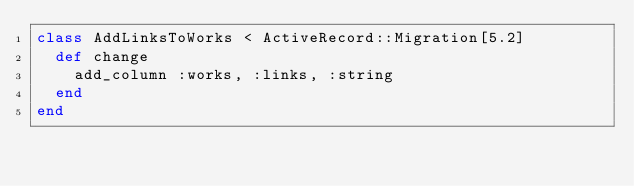Convert code to text. <code><loc_0><loc_0><loc_500><loc_500><_Ruby_>class AddLinksToWorks < ActiveRecord::Migration[5.2]
  def change
    add_column :works, :links, :string
  end
end
</code> 